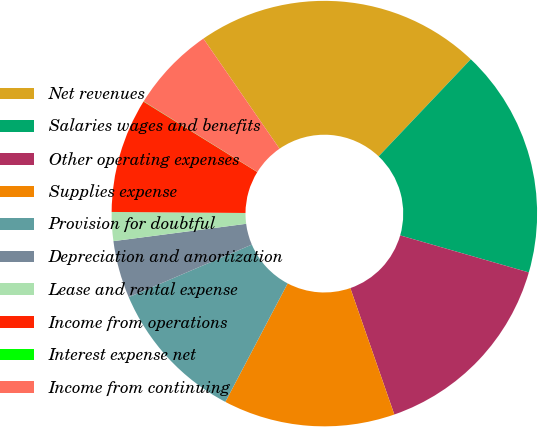Convert chart. <chart><loc_0><loc_0><loc_500><loc_500><pie_chart><fcel>Net revenues<fcel>Salaries wages and benefits<fcel>Other operating expenses<fcel>Supplies expense<fcel>Provision for doubtful<fcel>Depreciation and amortization<fcel>Lease and rental expense<fcel>Income from operations<fcel>Interest expense net<fcel>Income from continuing<nl><fcel>21.71%<fcel>17.38%<fcel>15.21%<fcel>13.04%<fcel>10.87%<fcel>4.36%<fcel>2.19%<fcel>8.7%<fcel>0.02%<fcel>6.53%<nl></chart> 